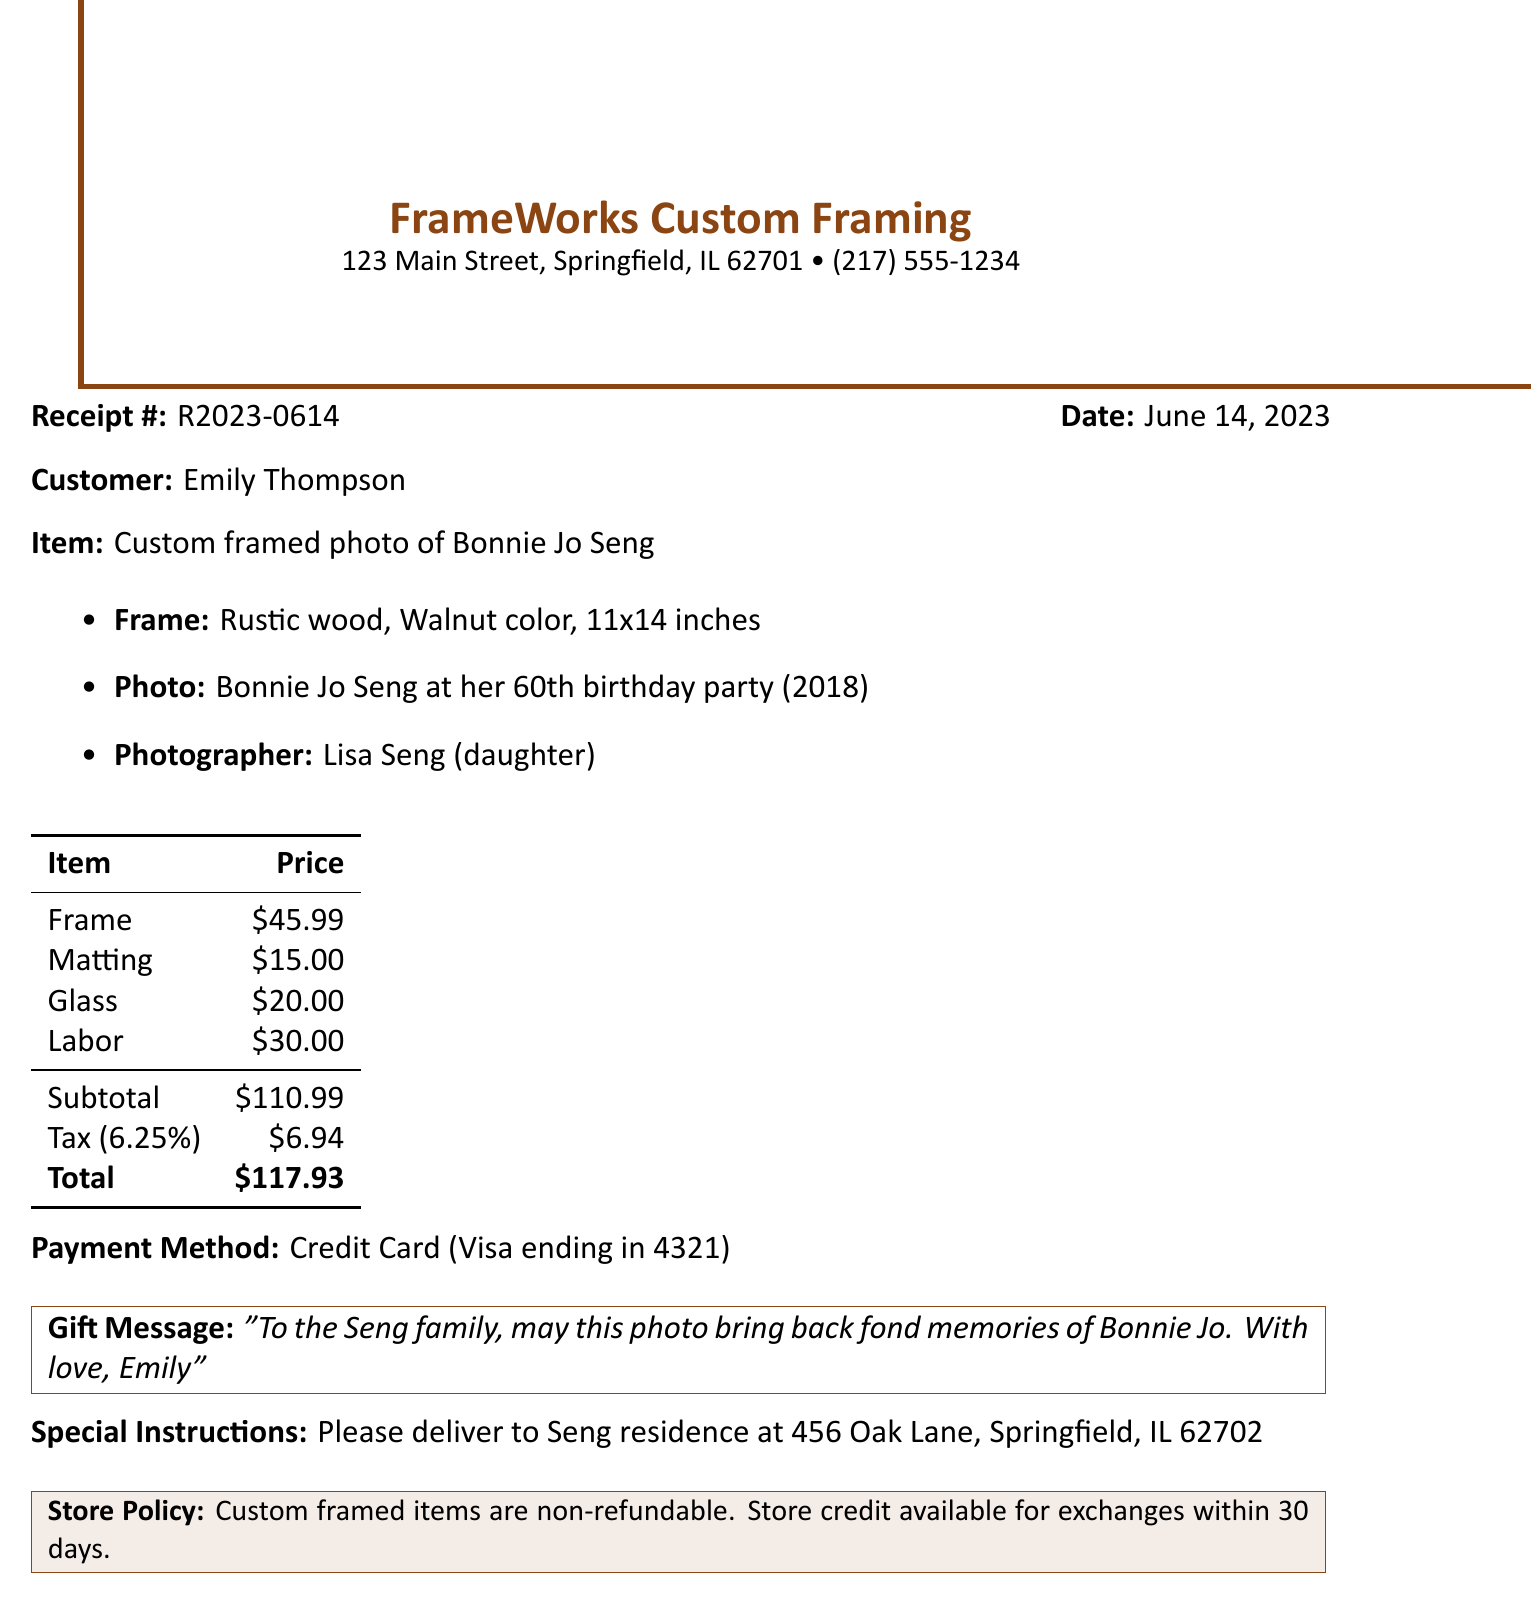What is the receipt number? The receipt number is specified at the top of the document for reference.
Answer: R2023-0614 What is the date of purchase? The date provides information on when the purchase was made.
Answer: June 14, 2023 Who is the vendor? The vendor's name is listed prominently on the receipt as the service provider.
Answer: FrameWorks Custom Framing What is the total amount charged? The total amount is the final cost to the customer after adding tax to the subtotal.
Answer: $117.93 What type of photo is framed? The description of the framed item tells what photo was customized.
Answer: Bonnie Jo Seng at her 60th birthday party What size is the frame? The size of the frame is indicated along with the style and color details.
Answer: 11x14 inches How much was charged for labor? The labor cost is included in the price breakdown section.
Answer: $30.00 What gift message was included? The gift message provides a personal touch to the purchase and is stated in the document.
Answer: "To the Seng family, may this photo bring back fond memories of Bonnie Jo. With love, Emily" What is the applicable tax rate? The tax rate is provided to calculate the final total from the subtotal.
Answer: 6.25% What special instructions were given for delivery? Special instructions indicate how and where the item should be delivered.
Answer: Please deliver to Seng residence at 456 Oak Lane, Springfield, IL 62702 